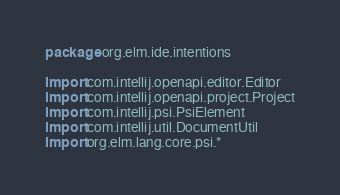<code> <loc_0><loc_0><loc_500><loc_500><_Kotlin_>package org.elm.ide.intentions

import com.intellij.openapi.editor.Editor
import com.intellij.openapi.project.Project
import com.intellij.psi.PsiElement
import com.intellij.util.DocumentUtil
import org.elm.lang.core.psi.*</code> 